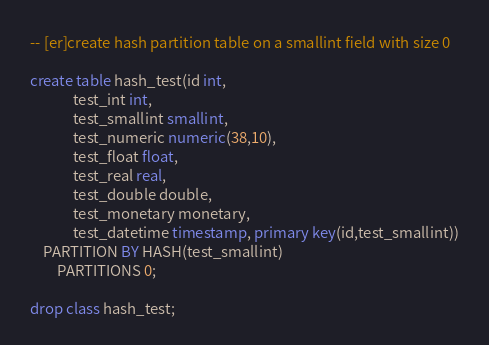<code> <loc_0><loc_0><loc_500><loc_500><_SQL_>-- [er]create hash partition table on a smallint field with size 0

create table hash_test(id int,
			 test_int int,
			 test_smallint smallint,
			 test_numeric numeric(38,10),
			 test_float float,
			 test_real real,
			 test_double double,
			 test_monetary monetary,
			 test_datetime timestamp, primary key(id,test_smallint))
	PARTITION BY HASH(test_smallint)
        PARTITIONS 0;

drop class hash_test;
</code> 